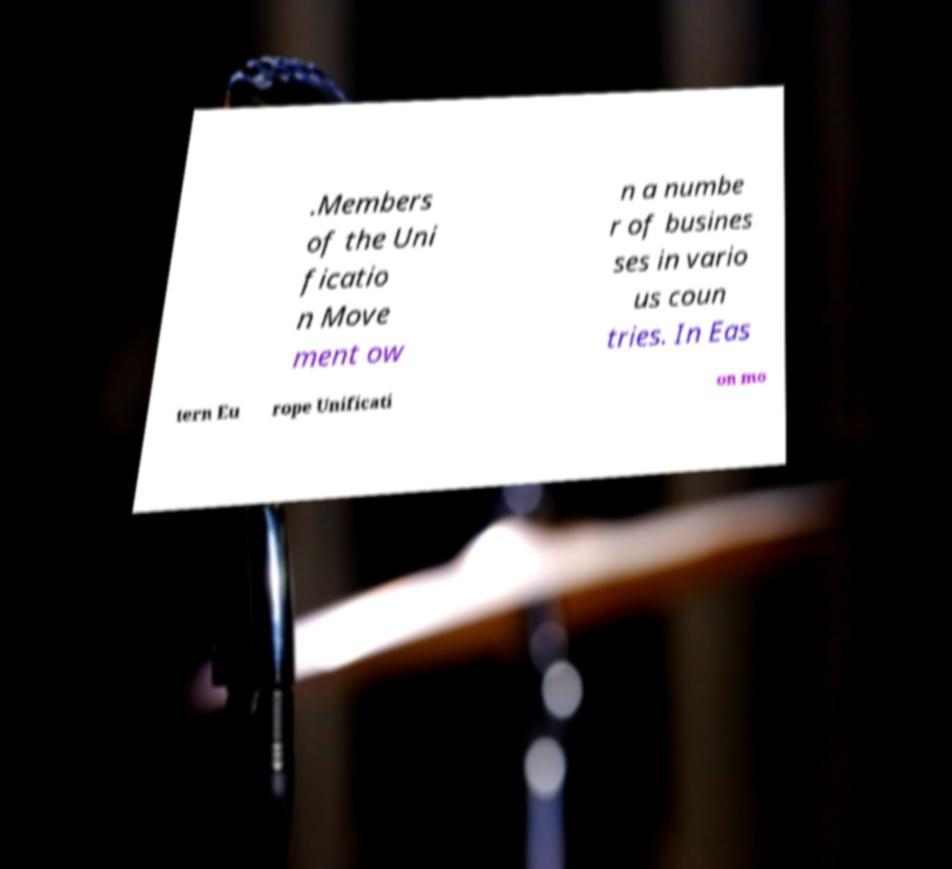Can you accurately transcribe the text from the provided image for me? .Members of the Uni ficatio n Move ment ow n a numbe r of busines ses in vario us coun tries. In Eas tern Eu rope Unificati on mo 